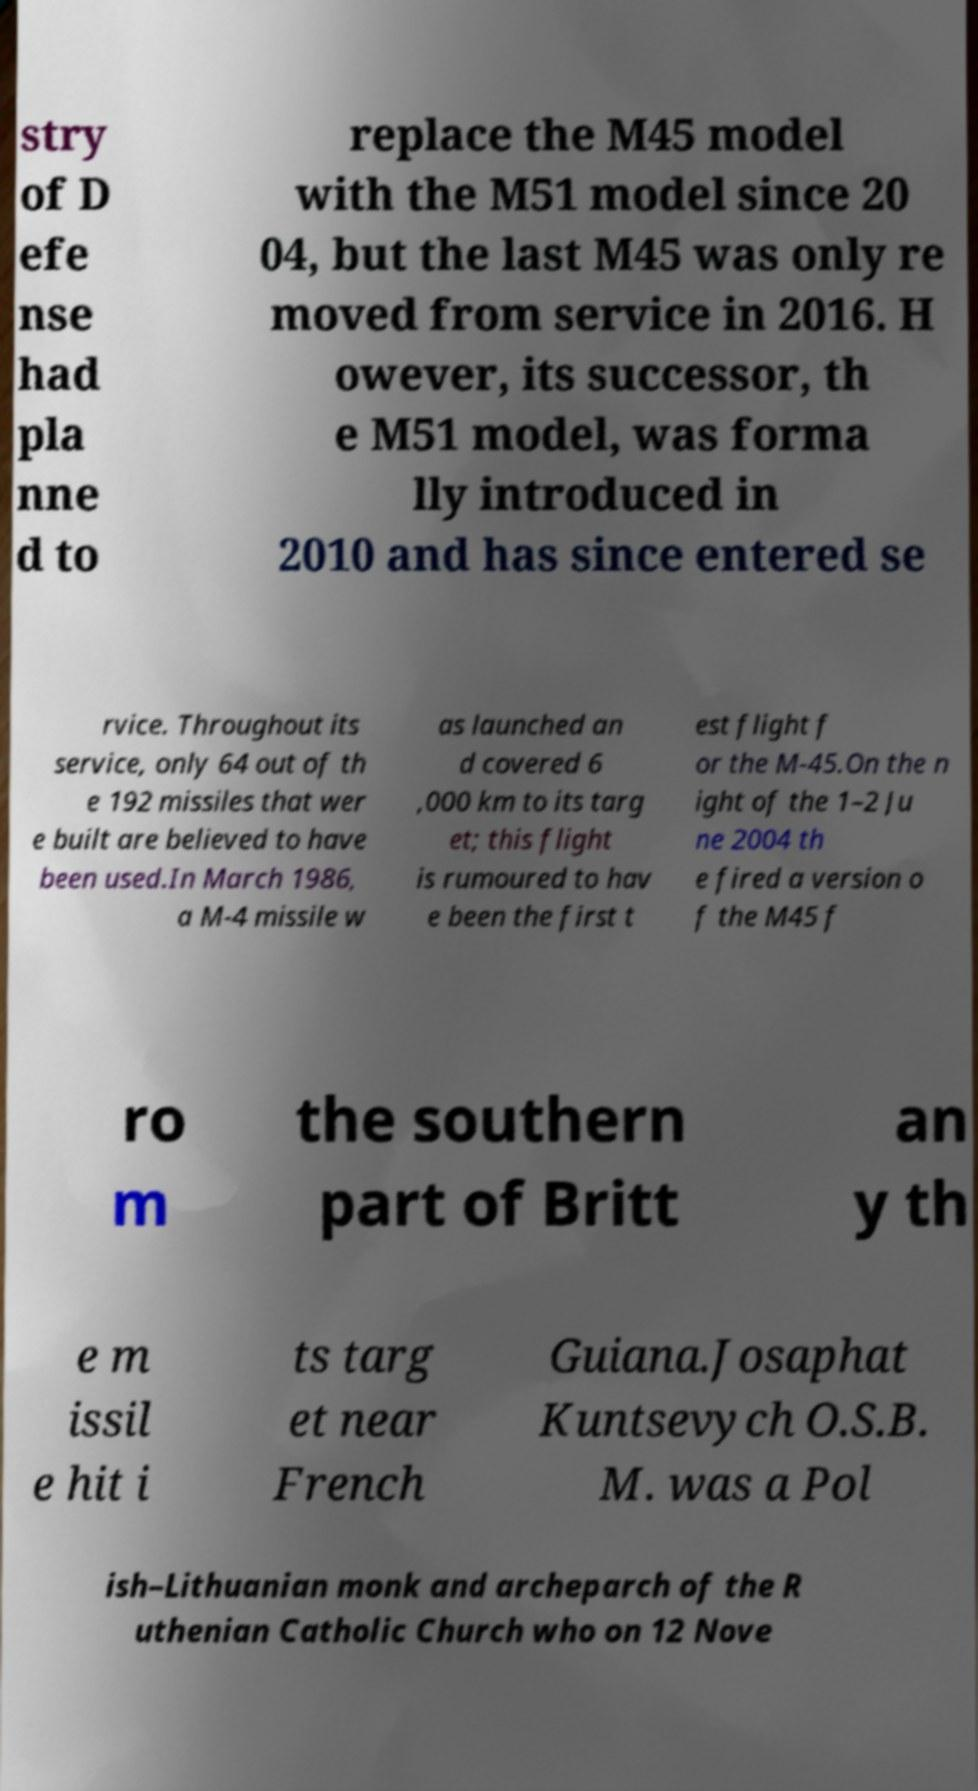There's text embedded in this image that I need extracted. Can you transcribe it verbatim? stry of D efe nse had pla nne d to replace the M45 model with the M51 model since 20 04, but the last M45 was only re moved from service in 2016. H owever, its successor, th e M51 model, was forma lly introduced in 2010 and has since entered se rvice. Throughout its service, only 64 out of th e 192 missiles that wer e built are believed to have been used.In March 1986, a M-4 missile w as launched an d covered 6 ,000 km to its targ et; this flight is rumoured to hav e been the first t est flight f or the M-45.On the n ight of the 1–2 Ju ne 2004 th e fired a version o f the M45 f ro m the southern part of Britt an y th e m issil e hit i ts targ et near French Guiana.Josaphat Kuntsevych O.S.B. M. was a Pol ish–Lithuanian monk and archeparch of the R uthenian Catholic Church who on 12 Nove 